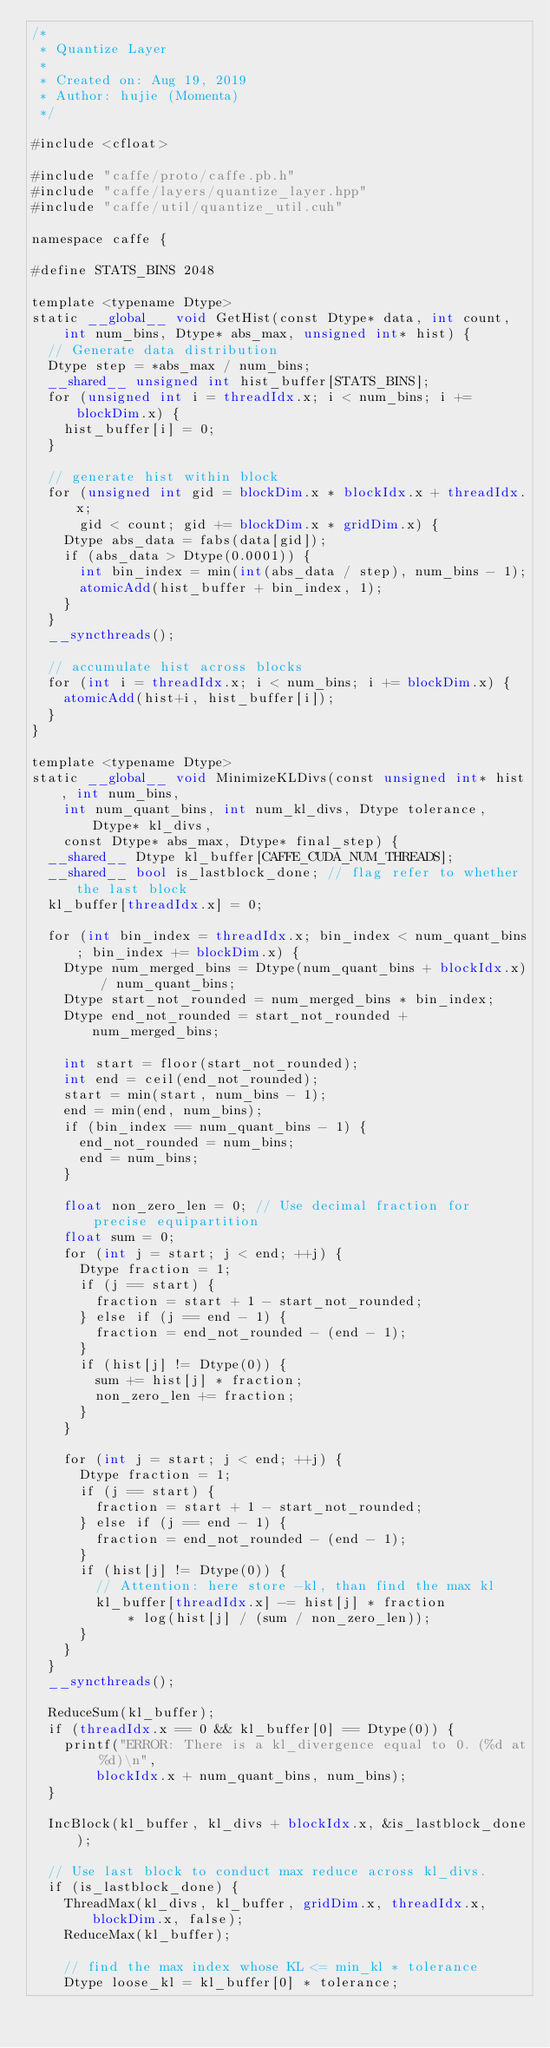Convert code to text. <code><loc_0><loc_0><loc_500><loc_500><_Cuda_>/*
 * Quantize Layer
 *
 * Created on: Aug 19, 2019
 * Author: hujie (Momenta)
 */

#include <cfloat>

#include "caffe/proto/caffe.pb.h"
#include "caffe/layers/quantize_layer.hpp"
#include "caffe/util/quantize_util.cuh"

namespace caffe {

#define STATS_BINS 2048

template <typename Dtype>
static __global__ void GetHist(const Dtype* data, int count,
    int num_bins, Dtype* abs_max, unsigned int* hist) {
  // Generate data distribution
  Dtype step = *abs_max / num_bins; 
  __shared__ unsigned int hist_buffer[STATS_BINS];
  for (unsigned int i = threadIdx.x; i < num_bins; i += blockDim.x) {
    hist_buffer[i] = 0;
  }
  
  // generate hist within block     
  for (unsigned int gid = blockDim.x * blockIdx.x + threadIdx.x;
      gid < count; gid += blockDim.x * gridDim.x) {
    Dtype abs_data = fabs(data[gid]);
    if (abs_data > Dtype(0.0001)) {
      int bin_index = min(int(abs_data / step), num_bins - 1);
      atomicAdd(hist_buffer + bin_index, 1);
    }
  }
  __syncthreads();

  // accumulate hist across blocks
  for (int i = threadIdx.x; i < num_bins; i += blockDim.x) {
    atomicAdd(hist+i, hist_buffer[i]);
  }
}

template <typename Dtype>
static __global__ void MinimizeKLDivs(const unsigned int* hist, int num_bins, 
    int num_quant_bins, int num_kl_divs, Dtype tolerance, Dtype* kl_divs, 
    const Dtype* abs_max, Dtype* final_step) {
  __shared__ Dtype kl_buffer[CAFFE_CUDA_NUM_THREADS];
  __shared__ bool is_lastblock_done; // flag refer to whether the last block
  kl_buffer[threadIdx.x] = 0;

  for (int bin_index = threadIdx.x; bin_index < num_quant_bins; bin_index += blockDim.x) {
    Dtype num_merged_bins = Dtype(num_quant_bins + blockIdx.x) / num_quant_bins;
    Dtype start_not_rounded = num_merged_bins * bin_index;
    Dtype end_not_rounded = start_not_rounded + num_merged_bins;

    int start = floor(start_not_rounded);
    int end = ceil(end_not_rounded);
    start = min(start, num_bins - 1);
    end = min(end, num_bins);
    if (bin_index == num_quant_bins - 1) {
      end_not_rounded = num_bins;
      end = num_bins;
    }

    float non_zero_len = 0; // Use decimal fraction for precise equipartition
    float sum = 0;
    for (int j = start; j < end; ++j) {
      Dtype fraction = 1;
      if (j == start) {
        fraction = start + 1 - start_not_rounded;
      } else if (j == end - 1) {
        fraction = end_not_rounded - (end - 1);
      }
      if (hist[j] != Dtype(0)) {
        sum += hist[j] * fraction;
        non_zero_len += fraction;
      }
    }
    
    for (int j = start; j < end; ++j) {
      Dtype fraction = 1;
      if (j == start) {
        fraction = start + 1 - start_not_rounded;
      } else if (j == end - 1) {
        fraction = end_not_rounded - (end - 1);
      }
      if (hist[j] != Dtype(0)) {
        // Attention: here store -kl, than find the max kl
        kl_buffer[threadIdx.x] -= hist[j] * fraction 
            * log(hist[j] / (sum / non_zero_len));
      }
    }
  }
  __syncthreads();
  
  ReduceSum(kl_buffer);
  if (threadIdx.x == 0 && kl_buffer[0] == Dtype(0)) {
    printf("ERROR: There is a kl_divergence equal to 0. (%d at %d)\n", 
        blockIdx.x + num_quant_bins, num_bins);
  }
 
  IncBlock(kl_buffer, kl_divs + blockIdx.x, &is_lastblock_done);

  // Use last block to conduct max reduce across kl_divs.
  if (is_lastblock_done) {
    ThreadMax(kl_divs, kl_buffer, gridDim.x, threadIdx.x, blockDim.x, false);
    ReduceMax(kl_buffer);
    
    // find the max index whose KL <= min_kl * tolerance
    Dtype loose_kl = kl_buffer[0] * tolerance;</code> 